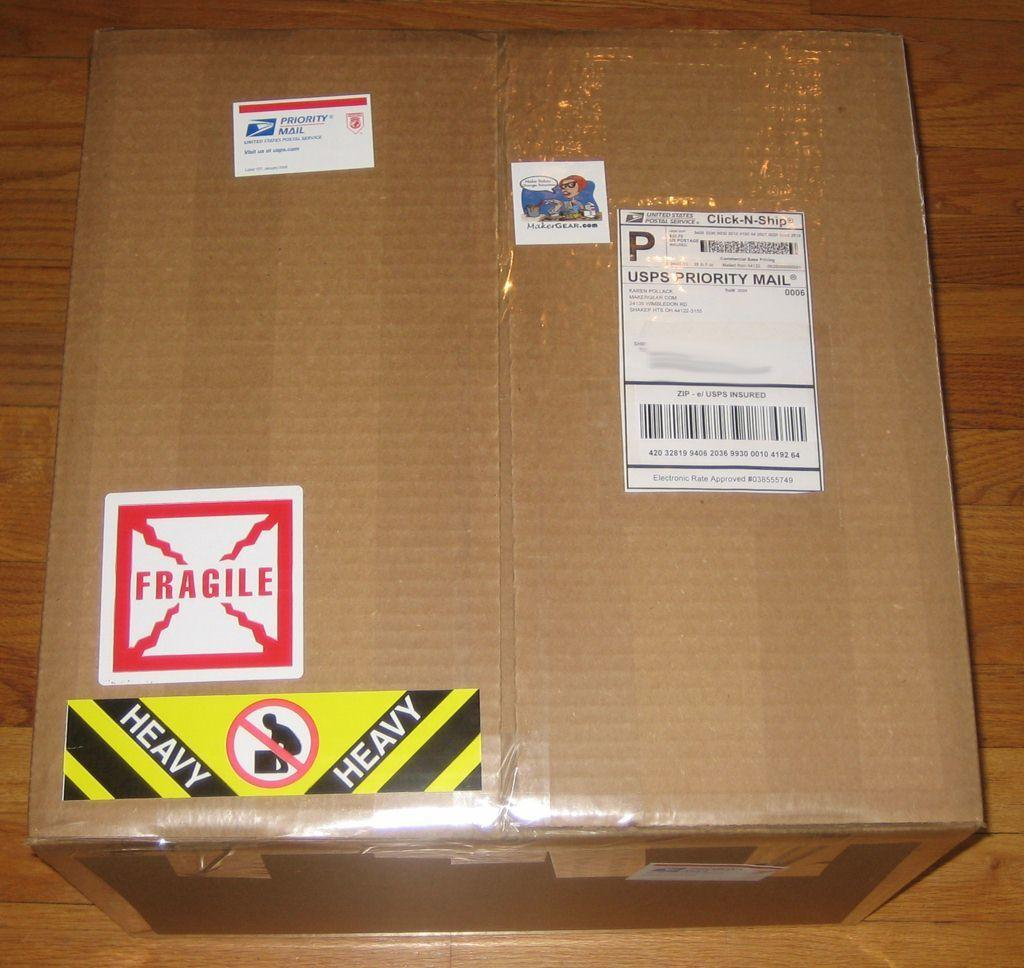<image>
Provide a brief description of the given image. A fragile package sent priority mail by Makergear.com 